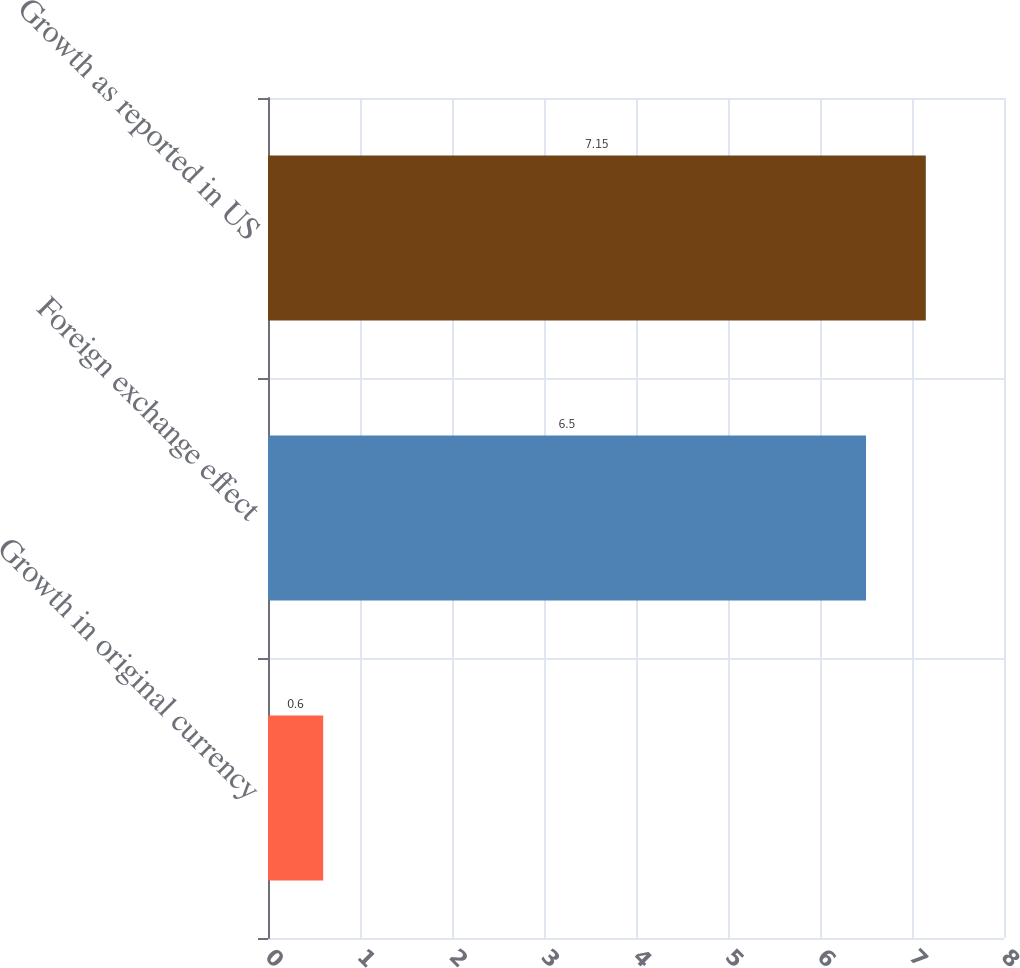<chart> <loc_0><loc_0><loc_500><loc_500><bar_chart><fcel>Growth in original currency<fcel>Foreign exchange effect<fcel>Growth as reported in US<nl><fcel>0.6<fcel>6.5<fcel>7.15<nl></chart> 